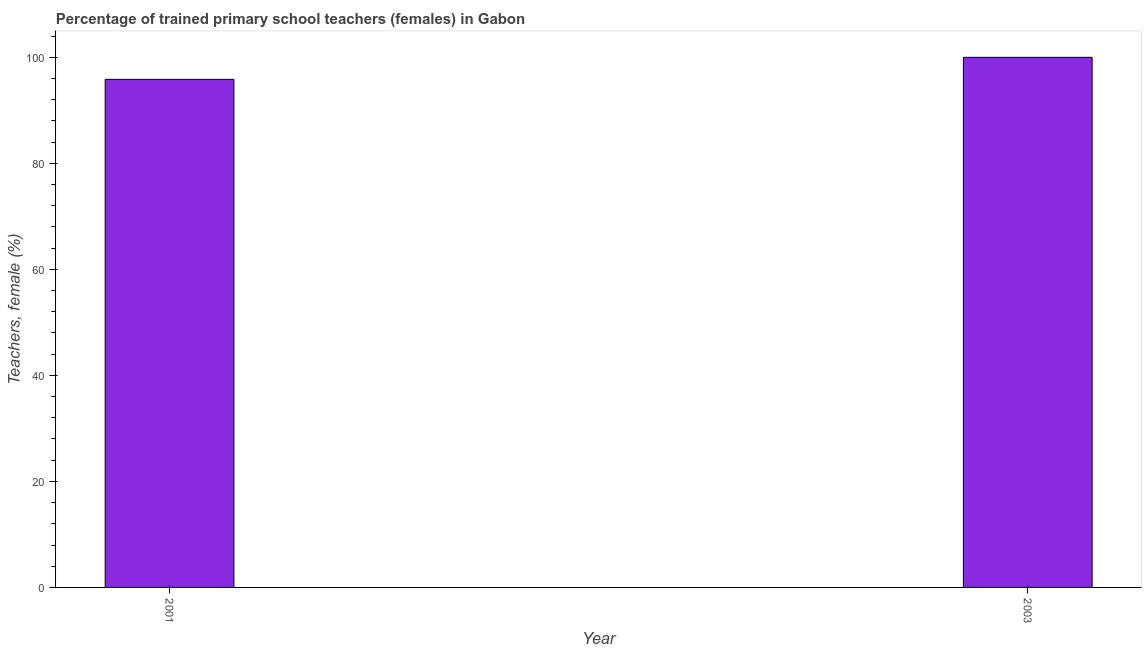Does the graph contain any zero values?
Provide a succinct answer. No. What is the title of the graph?
Your response must be concise. Percentage of trained primary school teachers (females) in Gabon. What is the label or title of the X-axis?
Your answer should be very brief. Year. What is the label or title of the Y-axis?
Make the answer very short. Teachers, female (%). What is the percentage of trained female teachers in 2001?
Provide a short and direct response. 95.85. Across all years, what is the maximum percentage of trained female teachers?
Ensure brevity in your answer.  100. Across all years, what is the minimum percentage of trained female teachers?
Your answer should be compact. 95.85. In which year was the percentage of trained female teachers minimum?
Your answer should be compact. 2001. What is the sum of the percentage of trained female teachers?
Your response must be concise. 195.85. What is the difference between the percentage of trained female teachers in 2001 and 2003?
Provide a succinct answer. -4.15. What is the average percentage of trained female teachers per year?
Make the answer very short. 97.92. What is the median percentage of trained female teachers?
Your answer should be very brief. 97.92. In how many years, is the percentage of trained female teachers greater than 44 %?
Provide a short and direct response. 2. Do a majority of the years between 2003 and 2001 (inclusive) have percentage of trained female teachers greater than 92 %?
Keep it short and to the point. No. What is the ratio of the percentage of trained female teachers in 2001 to that in 2003?
Give a very brief answer. 0.96. How many years are there in the graph?
Your answer should be very brief. 2. Are the values on the major ticks of Y-axis written in scientific E-notation?
Keep it short and to the point. No. What is the Teachers, female (%) in 2001?
Provide a succinct answer. 95.85. What is the Teachers, female (%) of 2003?
Your answer should be very brief. 100. What is the difference between the Teachers, female (%) in 2001 and 2003?
Provide a succinct answer. -4.15. What is the ratio of the Teachers, female (%) in 2001 to that in 2003?
Give a very brief answer. 0.96. 